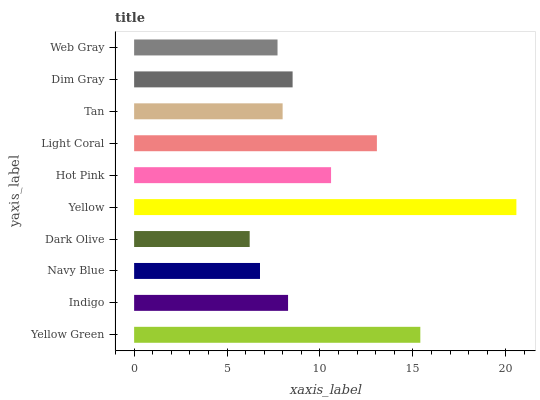Is Dark Olive the minimum?
Answer yes or no. Yes. Is Yellow the maximum?
Answer yes or no. Yes. Is Indigo the minimum?
Answer yes or no. No. Is Indigo the maximum?
Answer yes or no. No. Is Yellow Green greater than Indigo?
Answer yes or no. Yes. Is Indigo less than Yellow Green?
Answer yes or no. Yes. Is Indigo greater than Yellow Green?
Answer yes or no. No. Is Yellow Green less than Indigo?
Answer yes or no. No. Is Dim Gray the high median?
Answer yes or no. Yes. Is Indigo the low median?
Answer yes or no. Yes. Is Light Coral the high median?
Answer yes or no. No. Is Dark Olive the low median?
Answer yes or no. No. 